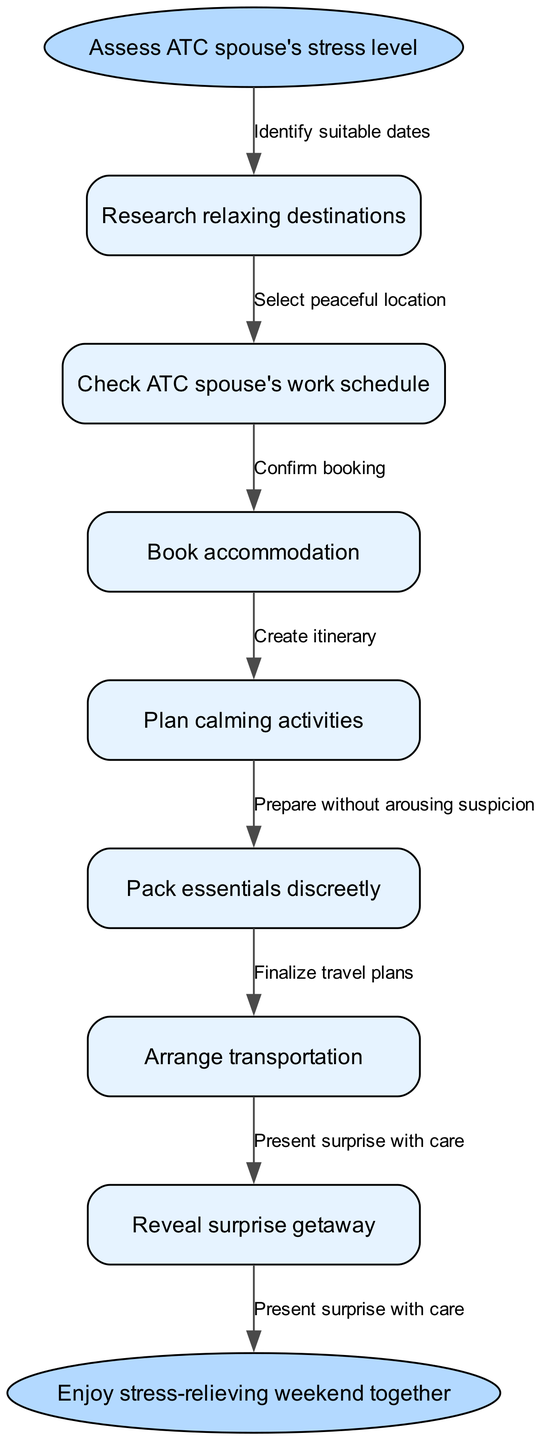What is the starting point of this workflow? The starting point of the workflow is "Assess ATC spouse's stress level." This is indicated as the first node in the diagram that connects to subsequent steps.
Answer: Assess ATC spouse's stress level How many nodes are there in total? The diagram contains 8 nodes, including the start node, the 6 workflow steps, and the end node. Therefore, by counting all the nodes, we arrive at 8.
Answer: 8 What is the last step before reaching the end node? The last step before reaching the end node is "Reveal surprise getaway", which connects directly to the end node in the diagram.
Answer: Reveal surprise getaway Which node follows "Plan calming activities"? The node that follows "Plan calming activities" is "Pack essentials discreetly." The diagram illustrates this connection in sequential order.
Answer: Pack essentials discreetly How many edges are there in this diagram? The diagram consists of 7 edges connecting the 8 nodes, representing the transitions between different steps in the workflow. By counting these connections, we find that there are 7 edges.
Answer: 7 What is the relation between "Research relaxing destinations" and "Select peaceful location"? "Research relaxing destinations" is the first node, which then leads to "Select peaceful location." This indicates an initial step that informs the selection of a suitable destination, demonstrating a cause-effect relationship.
Answer: Select peaceful location What do you need to do after "Confirm booking"? After "Confirm booking," the next step is "Create itinerary," as indicated by the directional flow in the diagram leading to the related task.
Answer: Create itinerary Which step involves preparing without arousing suspicion? The step involving preparing without arousing suspicion is "Pack essentials discreetly." This is emphasized in the workflow as a necessary action to maintain the element of surprise.
Answer: Pack essentials discreetly 